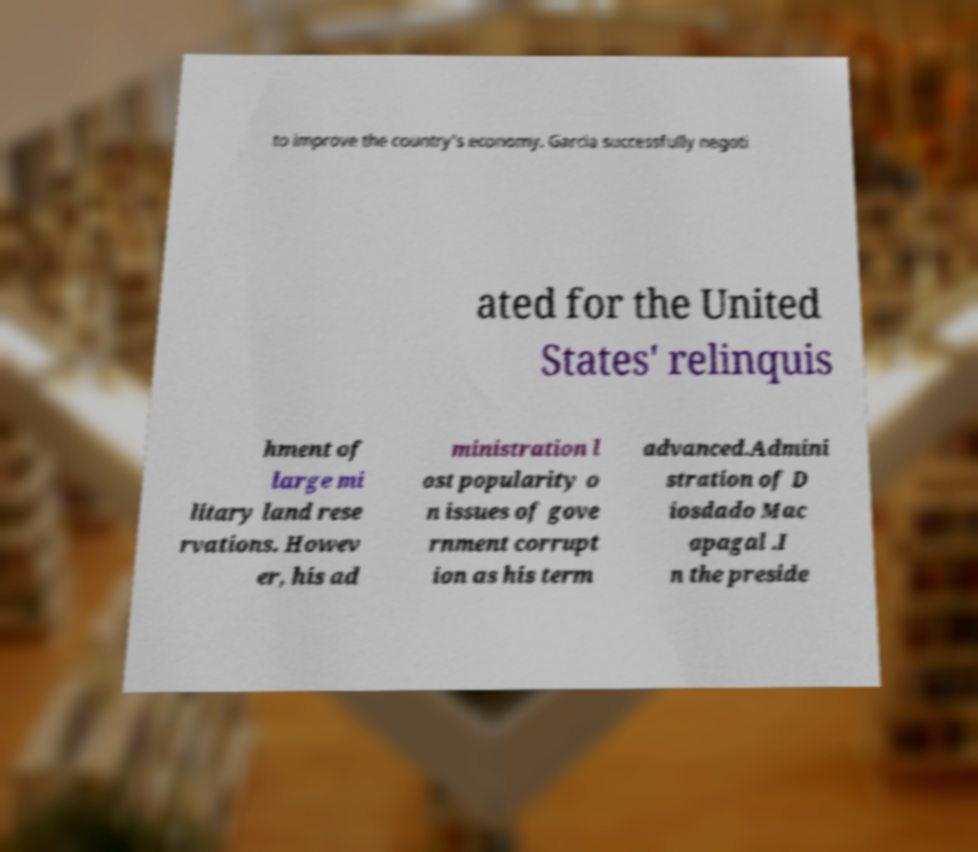Please read and relay the text visible in this image. What does it say? to improve the country's economy. Garcia successfully negoti ated for the United States' relinquis hment of large mi litary land rese rvations. Howev er, his ad ministration l ost popularity o n issues of gove rnment corrupt ion as his term advanced.Admini stration of D iosdado Mac apagal .I n the preside 